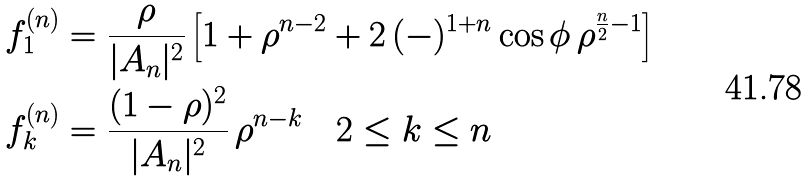<formula> <loc_0><loc_0><loc_500><loc_500>f _ { 1 } ^ { ( n ) } & = \frac { \rho } { | A _ { n } | ^ { 2 } } \left [ 1 + \rho ^ { n - 2 } + 2 \, ( - ) ^ { 1 + n } \cos \phi \, \rho ^ { \frac { n } { 2 } - 1 } \right ] \\ f _ { k } ^ { ( n ) } & = \frac { ( 1 - \rho ) ^ { 2 } } { | A _ { n } | ^ { 2 } } \, \rho ^ { n - k } \quad 2 \leq k \leq n</formula> 